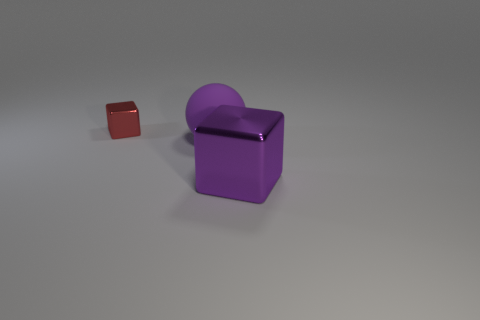The object that is made of the same material as the small red block is what color?
Give a very brief answer. Purple. What is the material of the tiny block?
Offer a terse response. Metal. There is a metal cube that is right of the thing behind the big purple thing that is left of the purple metallic block; what color is it?
Ensure brevity in your answer.  Purple. What number of purple blocks are the same size as the sphere?
Make the answer very short. 1. What color is the block behind the large purple shiny thing?
Provide a succinct answer. Red. What number of other objects are the same size as the red metallic block?
Ensure brevity in your answer.  0. What is the size of the object that is behind the big purple shiny block and right of the tiny metallic thing?
Offer a terse response. Large. Do the large rubber thing and the shiny block to the left of the large purple block have the same color?
Your answer should be very brief. No. Is there a small brown rubber object of the same shape as the tiny red thing?
Give a very brief answer. No. What number of things are either purple rubber objects or purple shiny blocks on the right side of the red cube?
Your answer should be very brief. 2. 